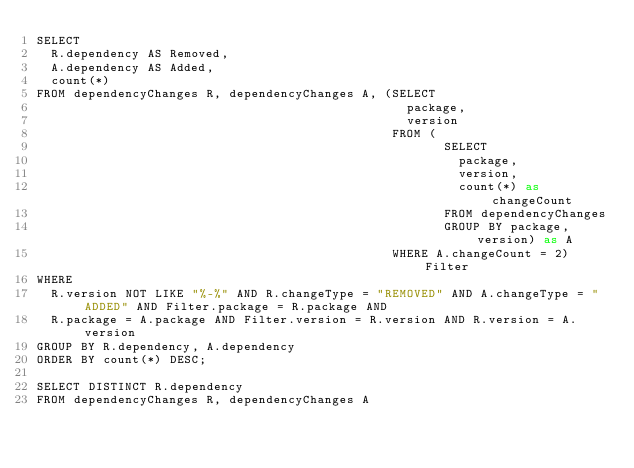Convert code to text. <code><loc_0><loc_0><loc_500><loc_500><_SQL_>SELECT
  R.dependency AS Removed,
  A.dependency AS Added,
  count(*)
FROM dependencyChanges R, dependencyChanges A, (SELECT
                                                  package,
                                                  version
                                                FROM (
                                                       SELECT
                                                         package,
                                                         version,
                                                         count(*) as changeCount
                                                       FROM dependencyChanges
                                                       GROUP BY package, version) as A
                                                WHERE A.changeCount = 2) Filter
WHERE
  R.version NOT LIKE "%-%" AND R.changeType = "REMOVED" AND A.changeType = "ADDED" AND Filter.package = R.package AND
  R.package = A.package AND Filter.version = R.version AND R.version = A.version
GROUP BY R.dependency, A.dependency
ORDER BY count(*) DESC;

SELECT DISTINCT R.dependency
FROM dependencyChanges R, dependencyChanges A</code> 